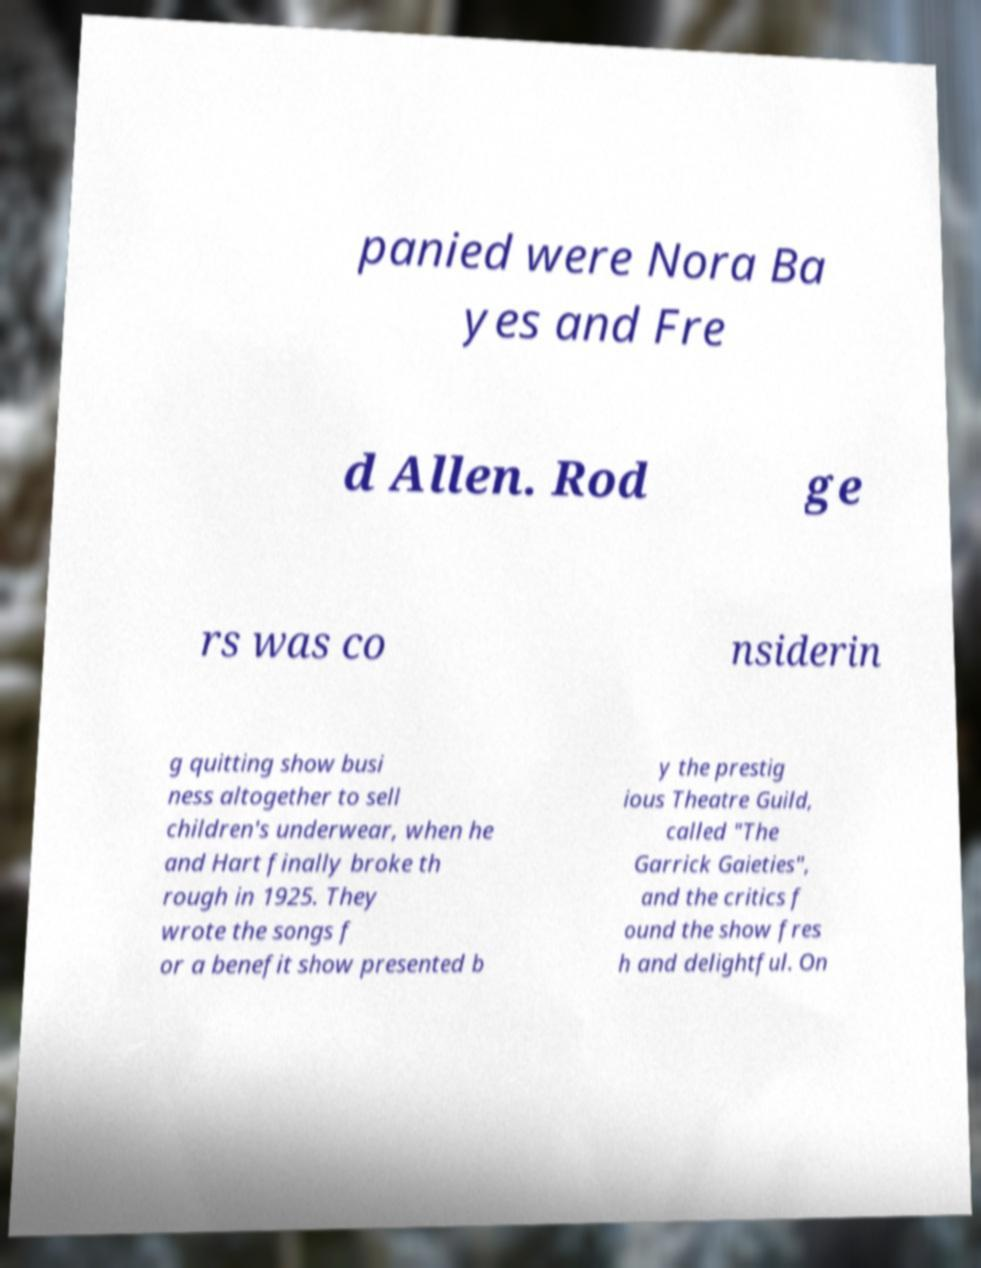Could you assist in decoding the text presented in this image and type it out clearly? panied were Nora Ba yes and Fre d Allen. Rod ge rs was co nsiderin g quitting show busi ness altogether to sell children's underwear, when he and Hart finally broke th rough in 1925. They wrote the songs f or a benefit show presented b y the prestig ious Theatre Guild, called "The Garrick Gaieties", and the critics f ound the show fres h and delightful. On 